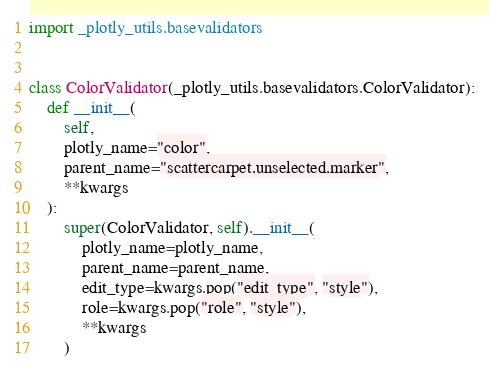Convert code to text. <code><loc_0><loc_0><loc_500><loc_500><_Python_>import _plotly_utils.basevalidators


class ColorValidator(_plotly_utils.basevalidators.ColorValidator):
    def __init__(
        self,
        plotly_name="color",
        parent_name="scattercarpet.unselected.marker",
        **kwargs
    ):
        super(ColorValidator, self).__init__(
            plotly_name=plotly_name,
            parent_name=parent_name,
            edit_type=kwargs.pop("edit_type", "style"),
            role=kwargs.pop("role", "style"),
            **kwargs
        )
</code> 